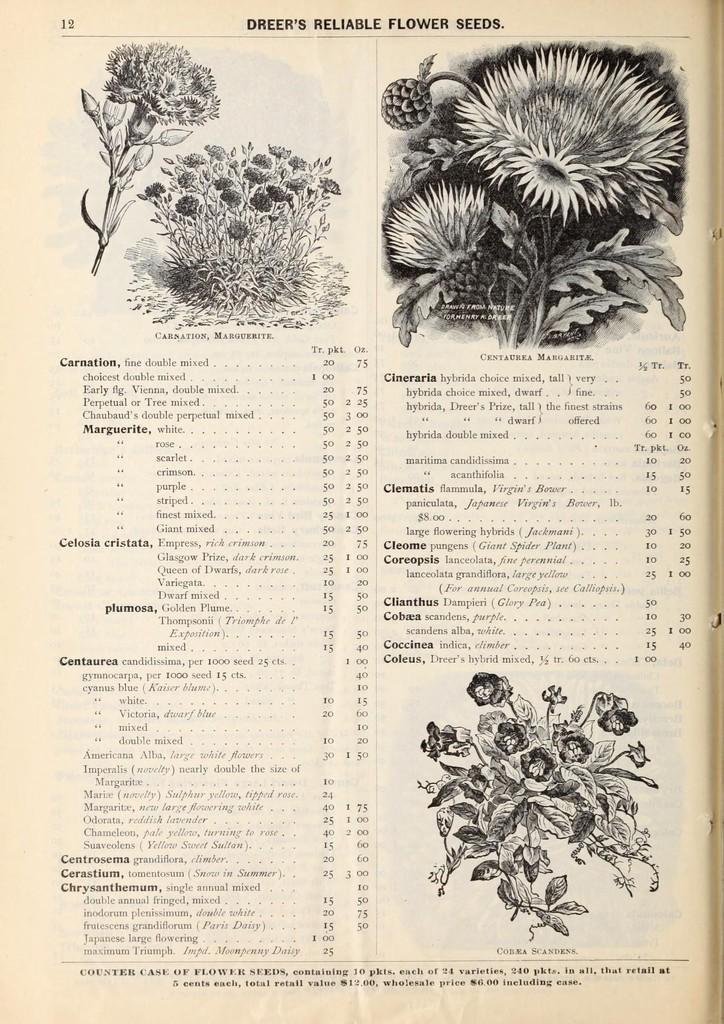Please provide a concise description of this image. In this image I can see the paper. On the paper I can see the plants with flowers and the text written. The paper is in black and cream color. 